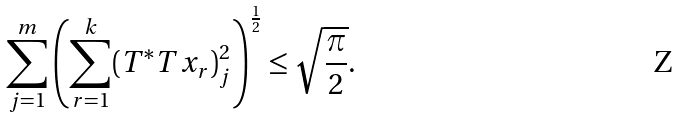Convert formula to latex. <formula><loc_0><loc_0><loc_500><loc_500>\sum _ { j = 1 } ^ { m } \left ( \sum _ { r = 1 } ^ { k } ( T ^ { * } T x _ { r } ) _ { j } ^ { 2 } \right ) ^ { \frac { 1 } { 2 } } \leq \sqrt { \frac { \pi } { 2 } } .</formula> 